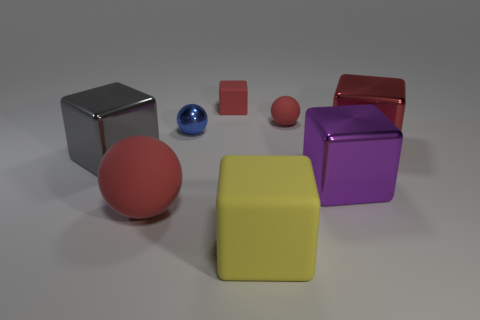Subtract all tiny balls. How many balls are left? 1 Subtract all yellow blocks. How many red spheres are left? 2 Add 1 brown metal blocks. How many objects exist? 9 Subtract all purple cubes. How many cubes are left? 4 Subtract all spheres. How many objects are left? 5 Subtract all small rubber spheres. Subtract all red rubber balls. How many objects are left? 5 Add 5 tiny red matte cubes. How many tiny red matte cubes are left? 6 Add 6 big purple rubber objects. How many big purple rubber objects exist? 6 Subtract 0 green spheres. How many objects are left? 8 Subtract all gray blocks. Subtract all green balls. How many blocks are left? 4 